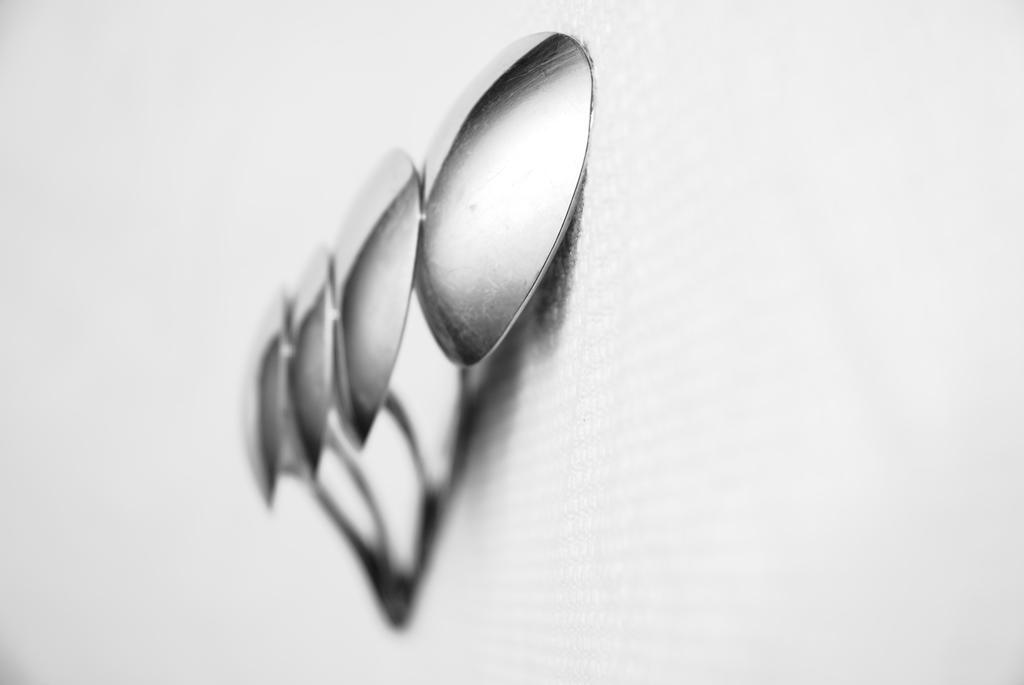Describe this image in one or two sentences. In this picture there are four steel spoons. At the bottom there is a white background. 